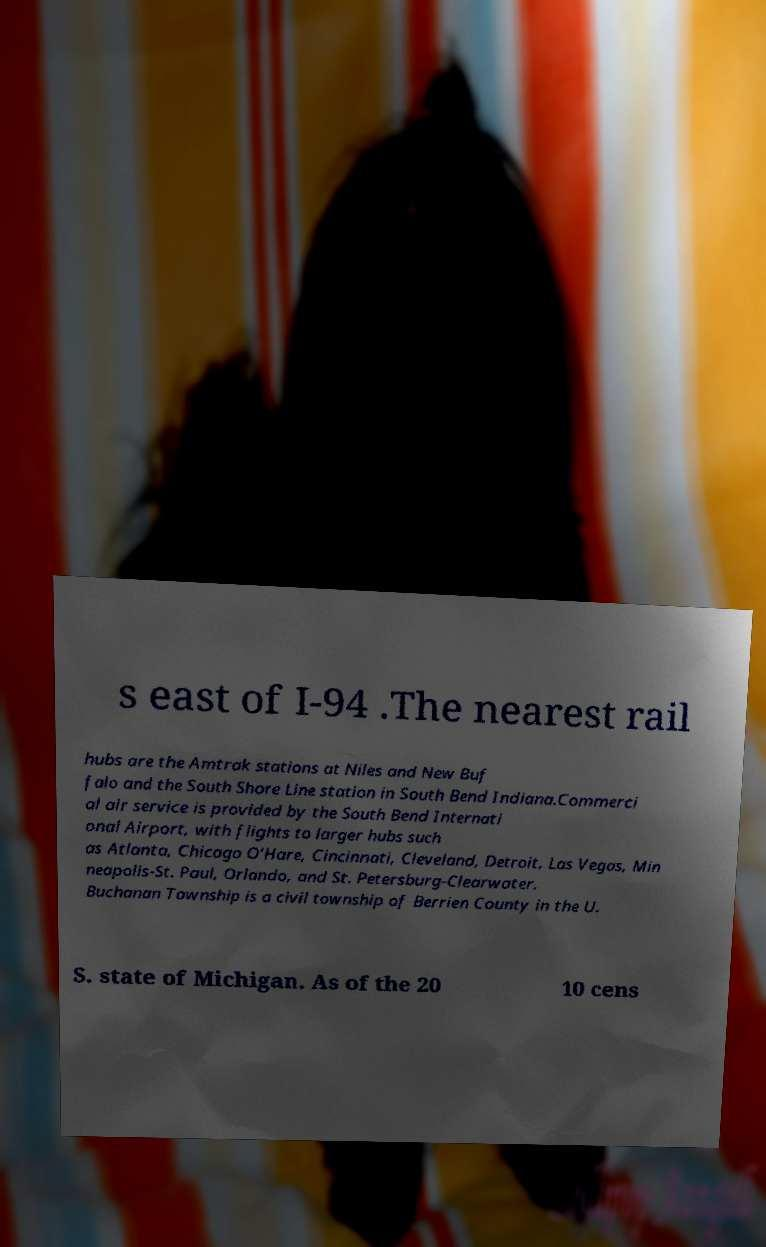Could you assist in decoding the text presented in this image and type it out clearly? s east of I-94 .The nearest rail hubs are the Amtrak stations at Niles and New Buf falo and the South Shore Line station in South Bend Indiana.Commerci al air service is provided by the South Bend Internati onal Airport, with flights to larger hubs such as Atlanta, Chicago O’Hare, Cincinnati, Cleveland, Detroit, Las Vegas, Min neapolis-St. Paul, Orlando, and St. Petersburg-Clearwater. Buchanan Township is a civil township of Berrien County in the U. S. state of Michigan. As of the 20 10 cens 